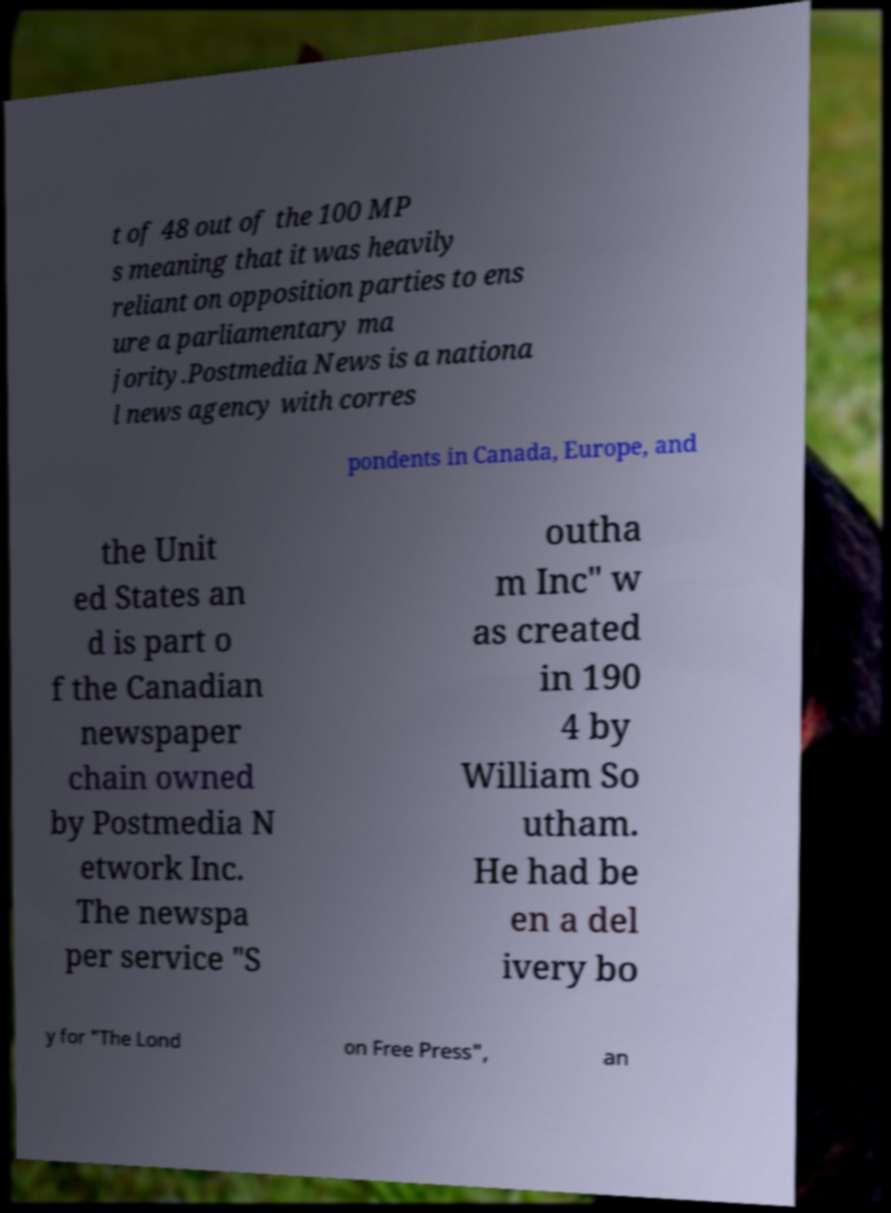There's text embedded in this image that I need extracted. Can you transcribe it verbatim? t of 48 out of the 100 MP s meaning that it was heavily reliant on opposition parties to ens ure a parliamentary ma jority.Postmedia News is a nationa l news agency with corres pondents in Canada, Europe, and the Unit ed States an d is part o f the Canadian newspaper chain owned by Postmedia N etwork Inc. The newspa per service "S outha m Inc" w as created in 190 4 by William So utham. He had be en a del ivery bo y for "The Lond on Free Press", an 